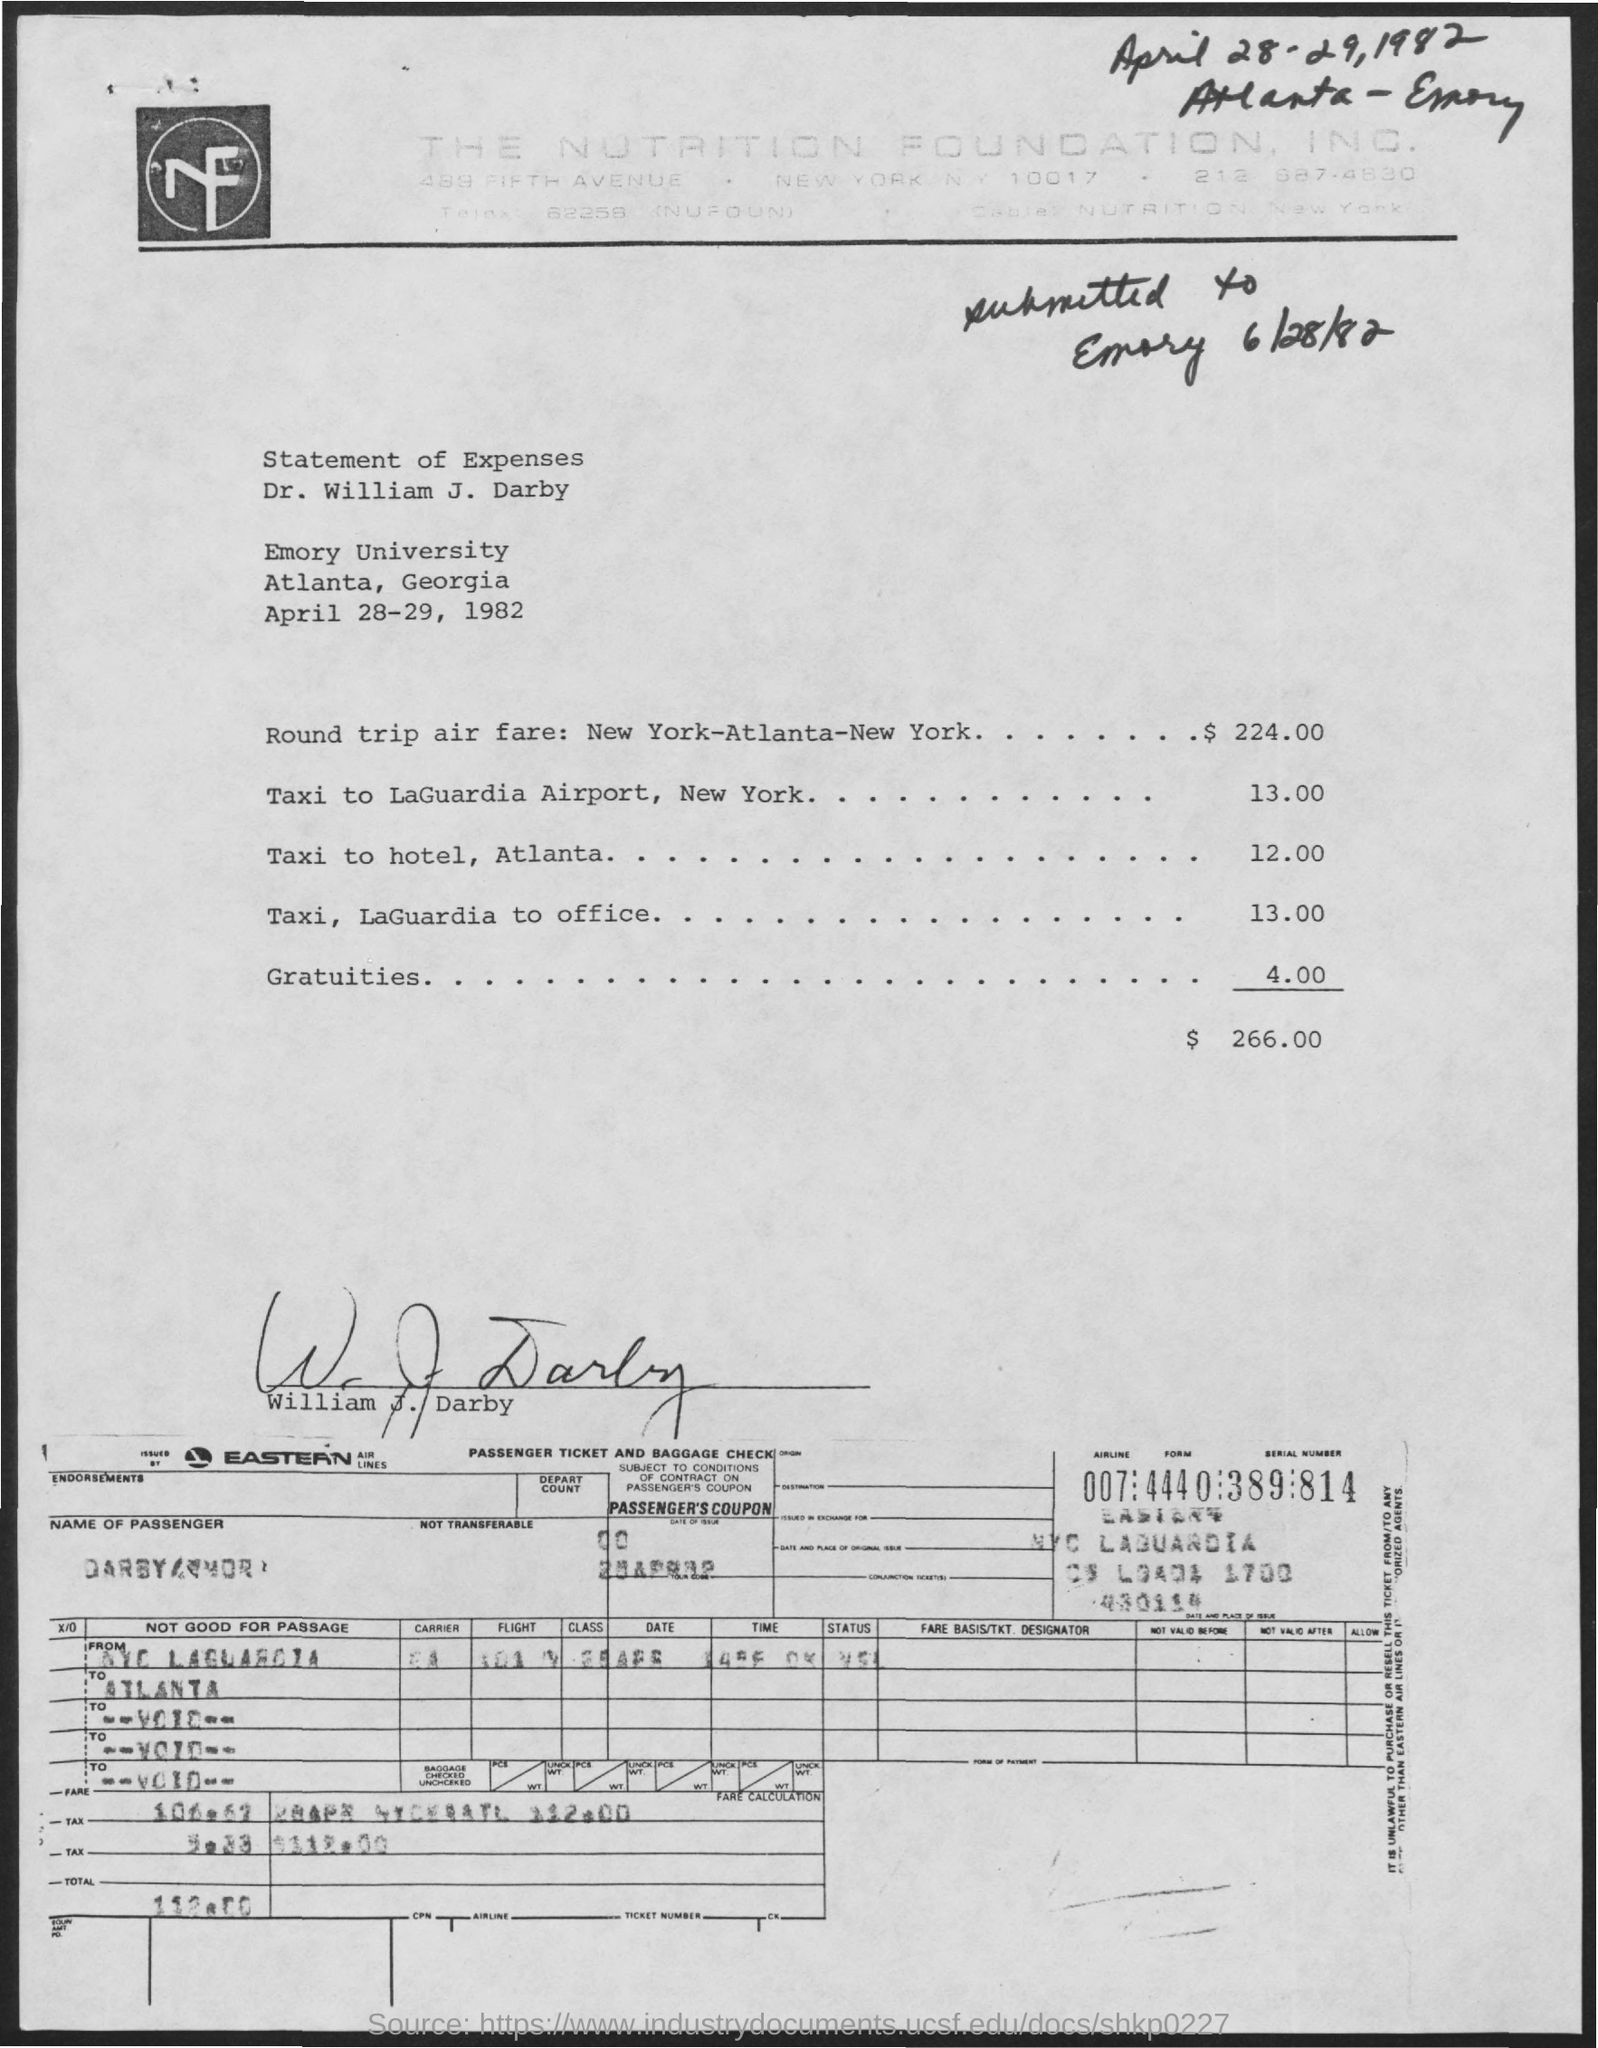What is the name of the foundation given in the letterhead?
Give a very brief answer. The Nutrition Foundation, Inc. What is the date mentioned at the top right of the document?
Your response must be concise. April 28-29,1982. What is the taxi fare to LaGuardia Airport?
Give a very brief answer. 13.00. 